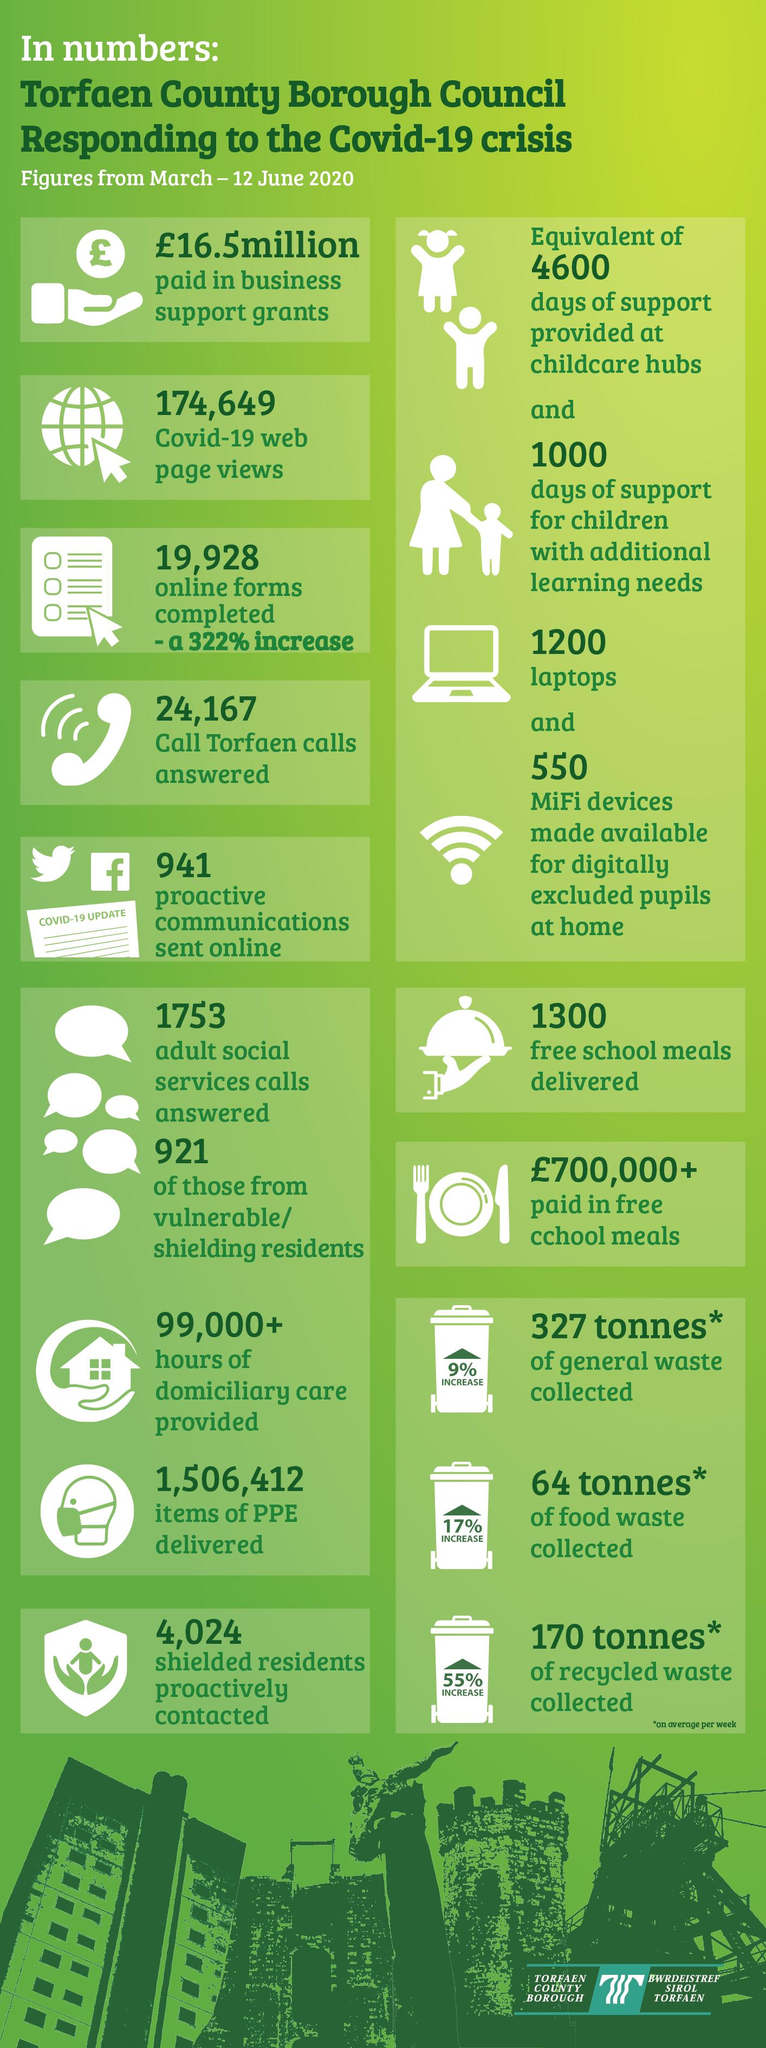Draw attention to some important aspects in this diagram. During the COVID-19 crisis, Torfaen Council received and answered 1,753 social service calls. The Torfaen Council delivered a total of 1,506,412 PPE kits during the Covid-19 crisis. During the COVID-19 crisis, Torfaen Council moved a total of 327 tonnes of general garbage. Torfaen Council has provided 1000 days of support for children with extra educational needs. During the COVID-19 crisis, Torfaen Council supplied a total of 1,300 free school food packets to assist affected individuals in the community. 